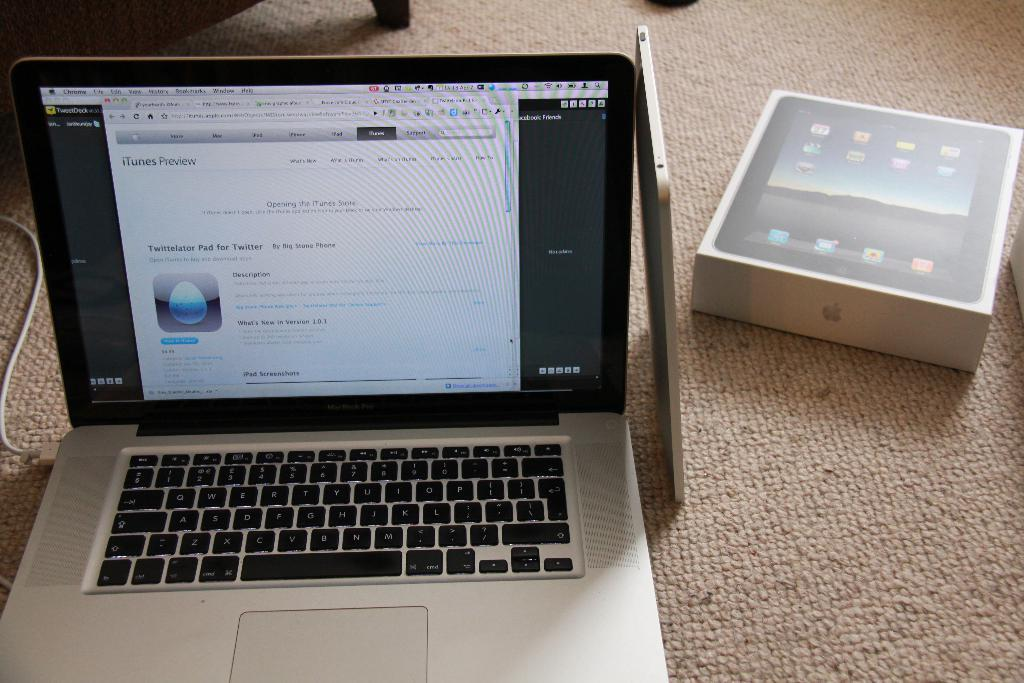<image>
Provide a brief description of the given image. Apple Macbook laptop with a screen that says "Opening the iTunes Store". 